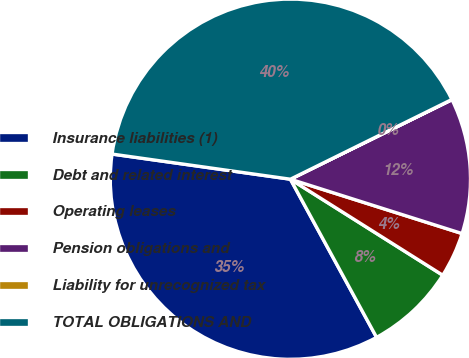Convert chart to OTSL. <chart><loc_0><loc_0><loc_500><loc_500><pie_chart><fcel>Insurance liabilities (1)<fcel>Debt and related interest<fcel>Operating leases<fcel>Pension obligations and<fcel>Liability for unrecognized tax<fcel>TOTAL OBLIGATIONS AND<nl><fcel>35.17%<fcel>8.11%<fcel>4.07%<fcel>12.16%<fcel>0.02%<fcel>40.47%<nl></chart> 